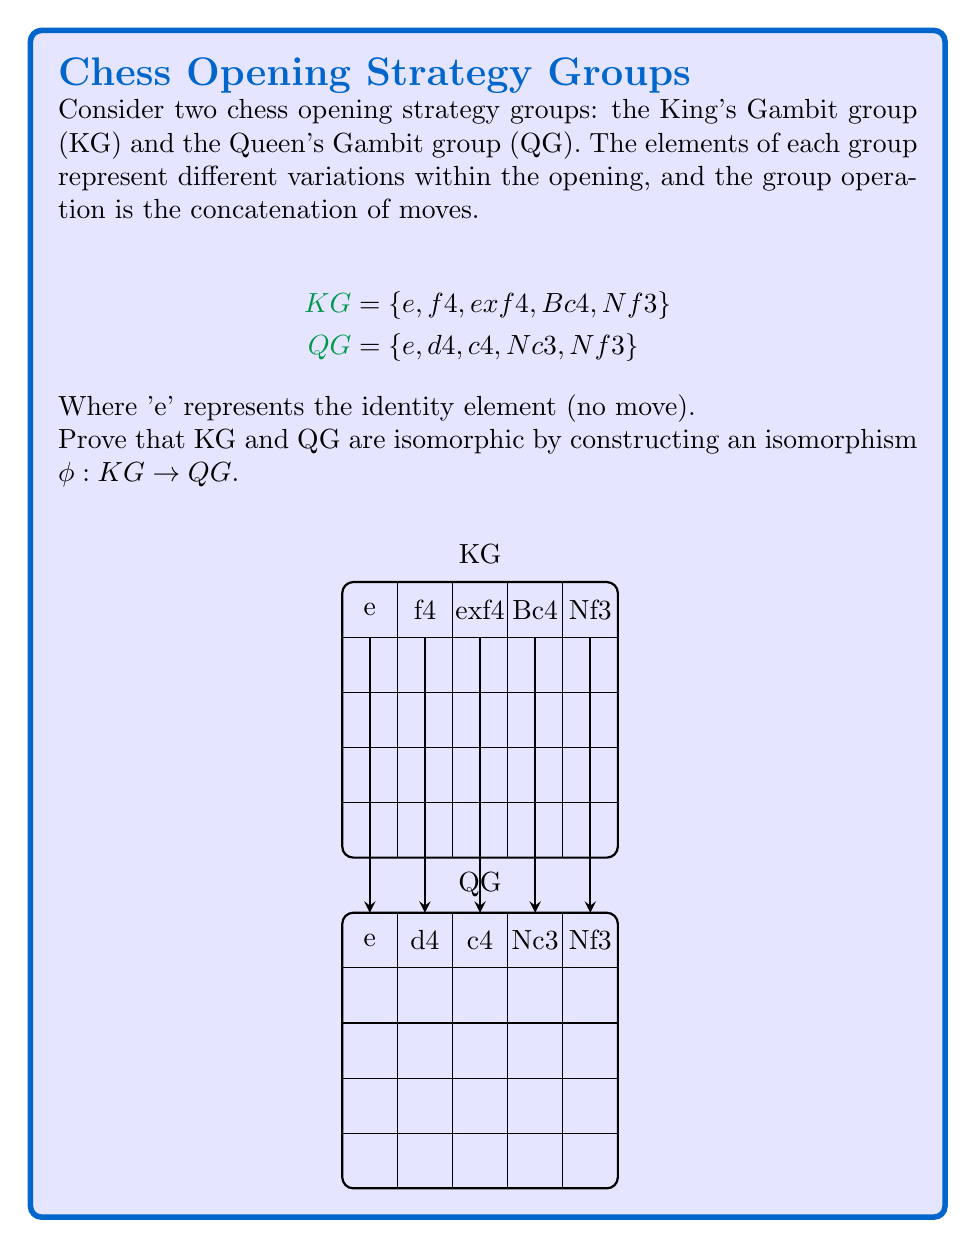Give your solution to this math problem. To prove that KG and QG are isomorphic, we need to construct a bijective homomorphism φ : KG → QG. Let's approach this step-by-step:

1) First, let's define our mapping φ:
   φ(e) = e
   φ(f4) = d4
   φ(exf4) = c4
   φ(Bc4) = Nc3
   φ(Nf3) = Nf3

2) To prove this is an isomorphism, we need to show that:
   a) φ is bijective (one-to-one and onto)
   b) φ preserves the group operation (homomorphism)

3) Proving φ is bijective:
   - It's one-to-one: each element in KG maps to a unique element in QG
   - It's onto: every element in QG is mapped to by an element in KG
   Thus, φ is bijective.

4) Proving φ is a homomorphism:
   We need to show that for any a, b ∈ KG, φ(ab) = φ(a)φ(b)

   Let's consider a few examples:
   
   a) φ(f4 • exf4) = φ(f4 • exf4) = φ(exf4) = c4
      φ(f4) • φ(exf4) = d4 • c4 = c4

   b) φ(Bc4 • Nf3) = φ(Bc4 • Nf3) = φ(Nf3) = Nf3
      φ(Bc4) • φ(Nf3) = Nc3 • Nf3 = Nf3

   c) φ(e • a) = φ(a) for any a ∈ KG
      φ(e) • φ(a) = e • φ(a) = φ(a)

5) The chess context:
   This isomorphism demonstrates that the structure of variations in the King's Gambit opening is fundamentally similar to that of the Queen's Gambit opening. While the specific moves differ, the relationships between the moves within each opening strategy are preserved.

6) Computational perspective:
   For a chess programming AI, this isomorphism could be leveraged to apply learned strategies from one opening to the other, potentially improving the AI's performance and reducing the amount of data needed for training.

Therefore, we have shown that φ is both bijective and a homomorphism, proving that KG and QG are isomorphic.
Answer: $\phi : \text{KG} \to \text{QG}$ defined by $\phi(e) = e$, $\phi(\text{f4}) = \text{d4}$, $\phi(\text{exf4}) = \text{c4}$, $\phi(\text{Bc4}) = \text{Nc3}$, $\phi(\text{Nf3}) = \text{Nf3}$ is an isomorphism. 